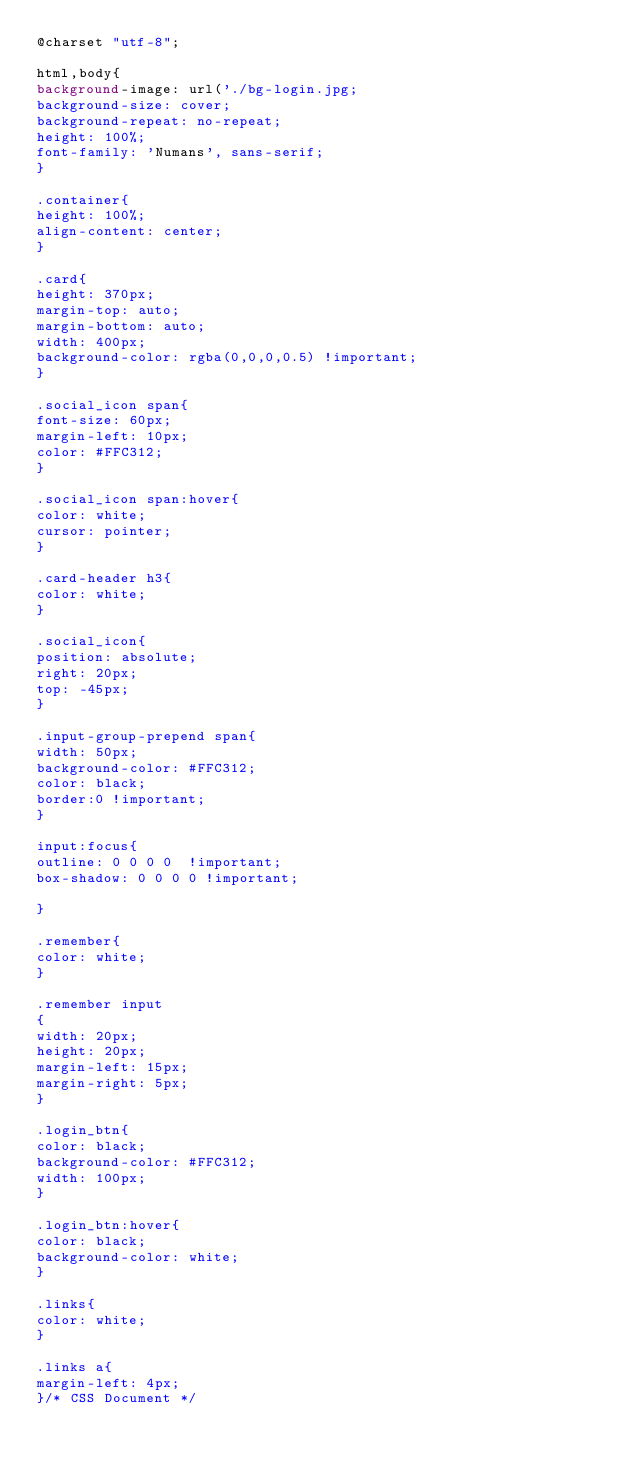<code> <loc_0><loc_0><loc_500><loc_500><_CSS_>@charset "utf-8";

html,body{
background-image: url('./bg-login.jpg;
background-size: cover;
background-repeat: no-repeat;
height: 100%;
font-family: 'Numans', sans-serif;
}

.container{
height: 100%;
align-content: center;
}

.card{
height: 370px;
margin-top: auto;
margin-bottom: auto;
width: 400px;
background-color: rgba(0,0,0,0.5) !important;
}

.social_icon span{
font-size: 60px;
margin-left: 10px;
color: #FFC312;
}

.social_icon span:hover{
color: white;
cursor: pointer;
}

.card-header h3{
color: white;
}

.social_icon{
position: absolute;
right: 20px;
top: -45px;
}

.input-group-prepend span{
width: 50px;
background-color: #FFC312;
color: black;
border:0 !important;
}

input:focus{
outline: 0 0 0 0  !important;
box-shadow: 0 0 0 0 !important;

}

.remember{
color: white;
}

.remember input
{
width: 20px;
height: 20px;
margin-left: 15px;
margin-right: 5px;
}

.login_btn{
color: black;
background-color: #FFC312;
width: 100px;
}

.login_btn:hover{
color: black;
background-color: white;
}

.links{
color: white;
}

.links a{
margin-left: 4px;
}/* CSS Document */

</code> 